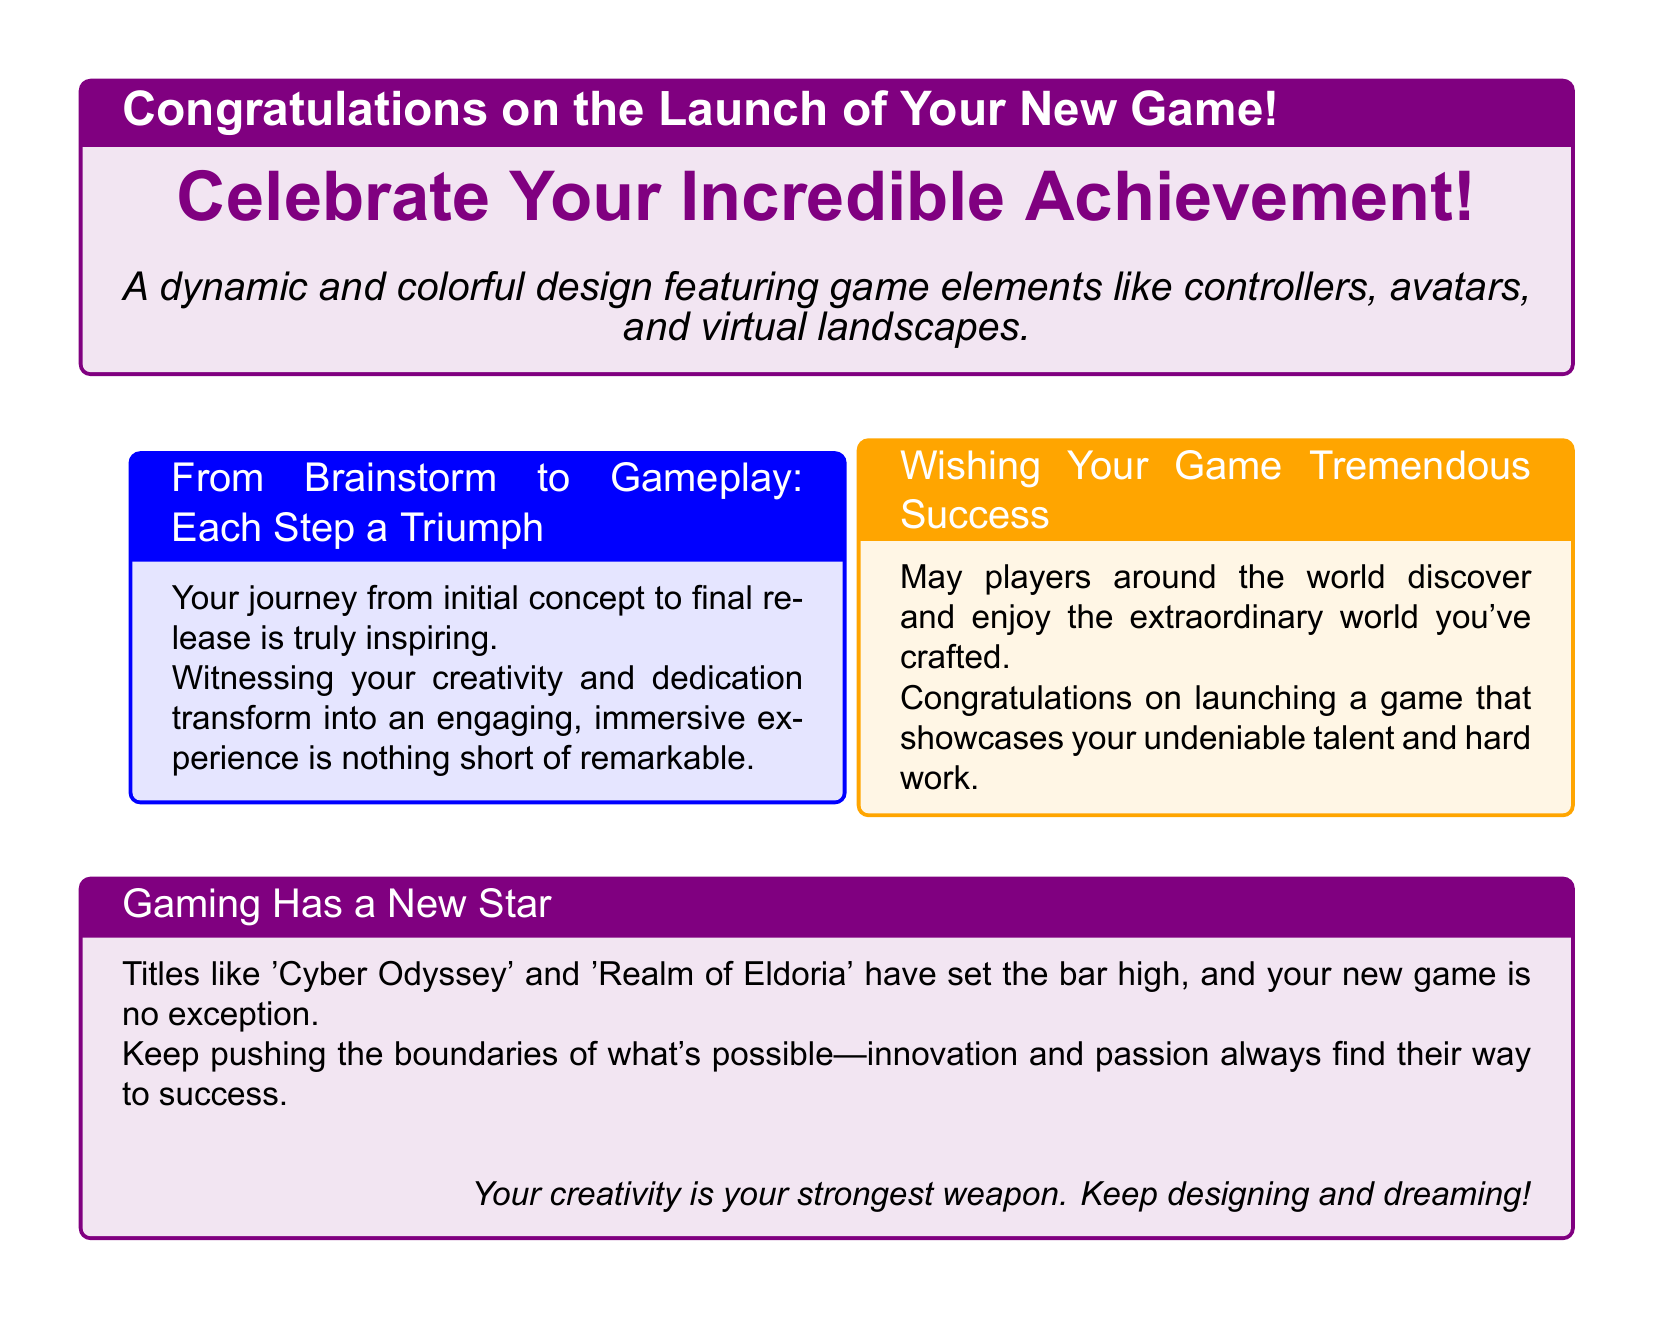What is the title of the card? The title of the card is presented prominently at the top, celebrating the occasion of a new game launch.
Answer: Congratulations on the Launch of Your New Game! Which color is used for the main background of the title box? The title box has a background color that is a lighter shade of purple, specifically designed to convey a celebratory feel.
Answer: Light purple What is one of the featured game elements mentioned in the card? The document describes various game elements that are part of the colorful design, showcasing the gaming theme.
Answer: Controllers What is the name of one game that is compared to the new game in the card? The card mentions notable titles as a benchmark for the innovation of the new game, establishing context for its success.
Answer: Cyber Odyssey What is the sentiment expressed towards the game designer's journey? The document conveys admiration for the designer's hard work and creativity, reinforcing the inspirational aspect of the gaming industry.
Answer: Inspiring How does the card wish success for the new game? The card expresses hopes that players around the world will engage with the designer's creation, indicating a global outreach.
Answer: Tremendous Success What does the last box encourage the game designer to do? The final message in the card inspires the designer to continue their creative pursuits and maintain their passion for game design.
Answer: Keep designing and dreaming! 